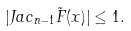Convert formula to latex. <formula><loc_0><loc_0><loc_500><loc_500>| J a c _ { n - 1 } \tilde { F } ( x ) | \leq 1 .</formula> 